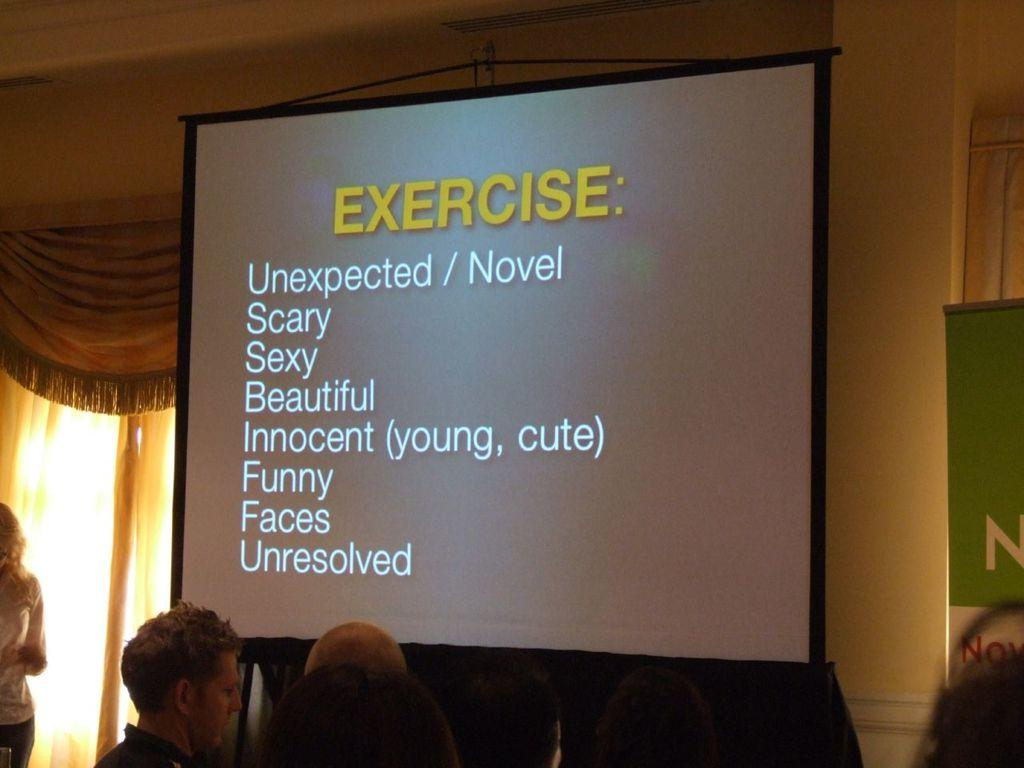What device is visible in the image? There is a projector in the image. What is being displayed by the projector? The projector displays some text. Who is present in the image? There are people in the image. What type of window treatment is present in the image? There are curtains in the image. What surface is the text being projected onto? There is a board in the image. What is the background of the image? There is a wall in the image. Can you see a volcano erupting in the image? No, there is no volcano or any indication of an eruption in the image. How many times do the people in the image sneeze? There is no information about sneezing or any such activity in the image. 